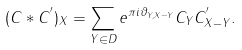Convert formula to latex. <formula><loc_0><loc_0><loc_500><loc_500>( C * C ^ { ^ { \prime } } ) _ { X } = \sum _ { Y \in D } e ^ { \pi i \vartheta _ { Y , X - Y } } C _ { Y } C _ { X - Y } ^ { ^ { \prime } } .</formula> 